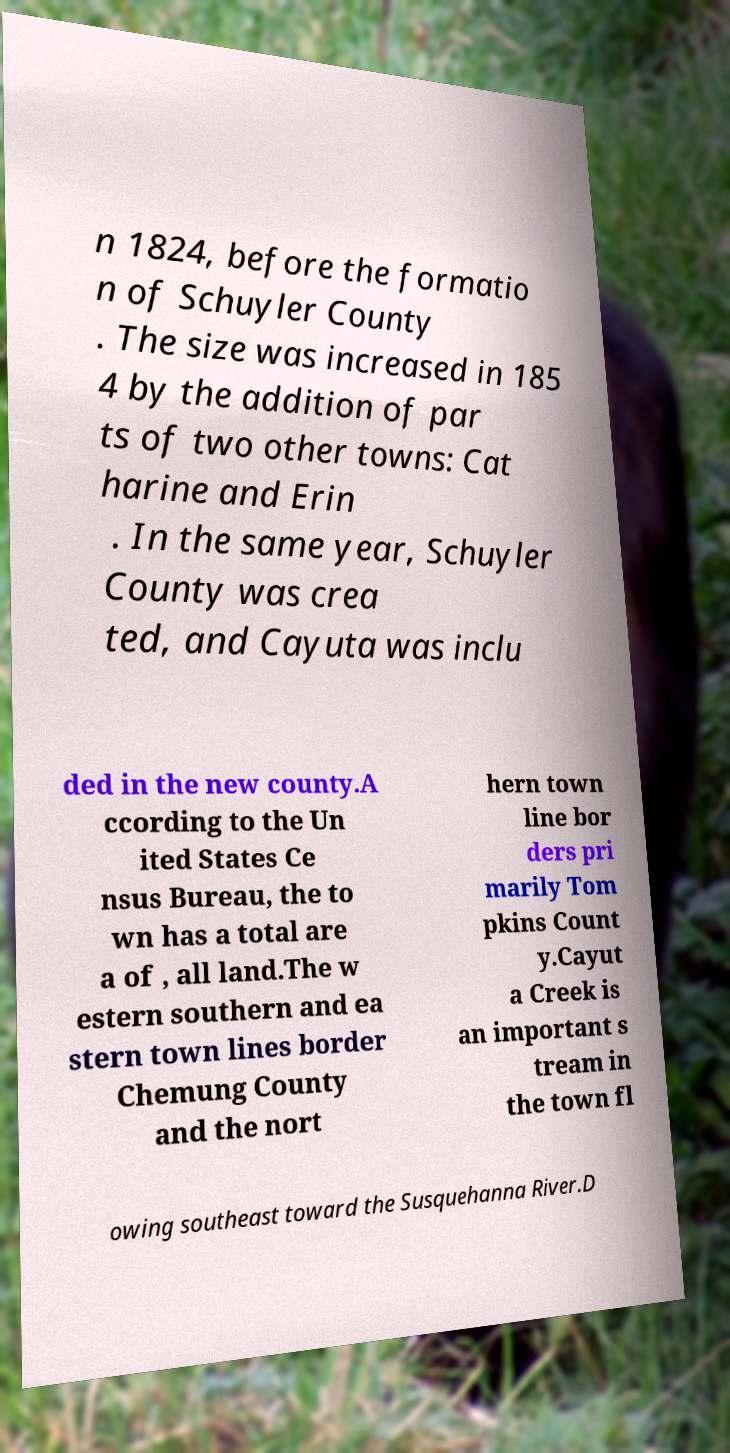Can you read and provide the text displayed in the image?This photo seems to have some interesting text. Can you extract and type it out for me? n 1824, before the formatio n of Schuyler County . The size was increased in 185 4 by the addition of par ts of two other towns: Cat harine and Erin . In the same year, Schuyler County was crea ted, and Cayuta was inclu ded in the new county.A ccording to the Un ited States Ce nsus Bureau, the to wn has a total are a of , all land.The w estern southern and ea stern town lines border Chemung County and the nort hern town line bor ders pri marily Tom pkins Count y.Cayut a Creek is an important s tream in the town fl owing southeast toward the Susquehanna River.D 